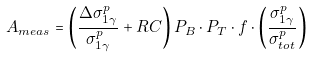Convert formula to latex. <formula><loc_0><loc_0><loc_500><loc_500>A _ { m e a s } = \left ( \frac { \Delta \sigma _ { 1 \gamma } ^ { p } } { \sigma _ { 1 \gamma } ^ { p } } + R C \right ) P _ { B } \cdot P _ { T } \cdot f \cdot \left ( \frac { \sigma _ { 1 \gamma } ^ { p } } { \sigma _ { t o t } ^ { p } } \right )</formula> 